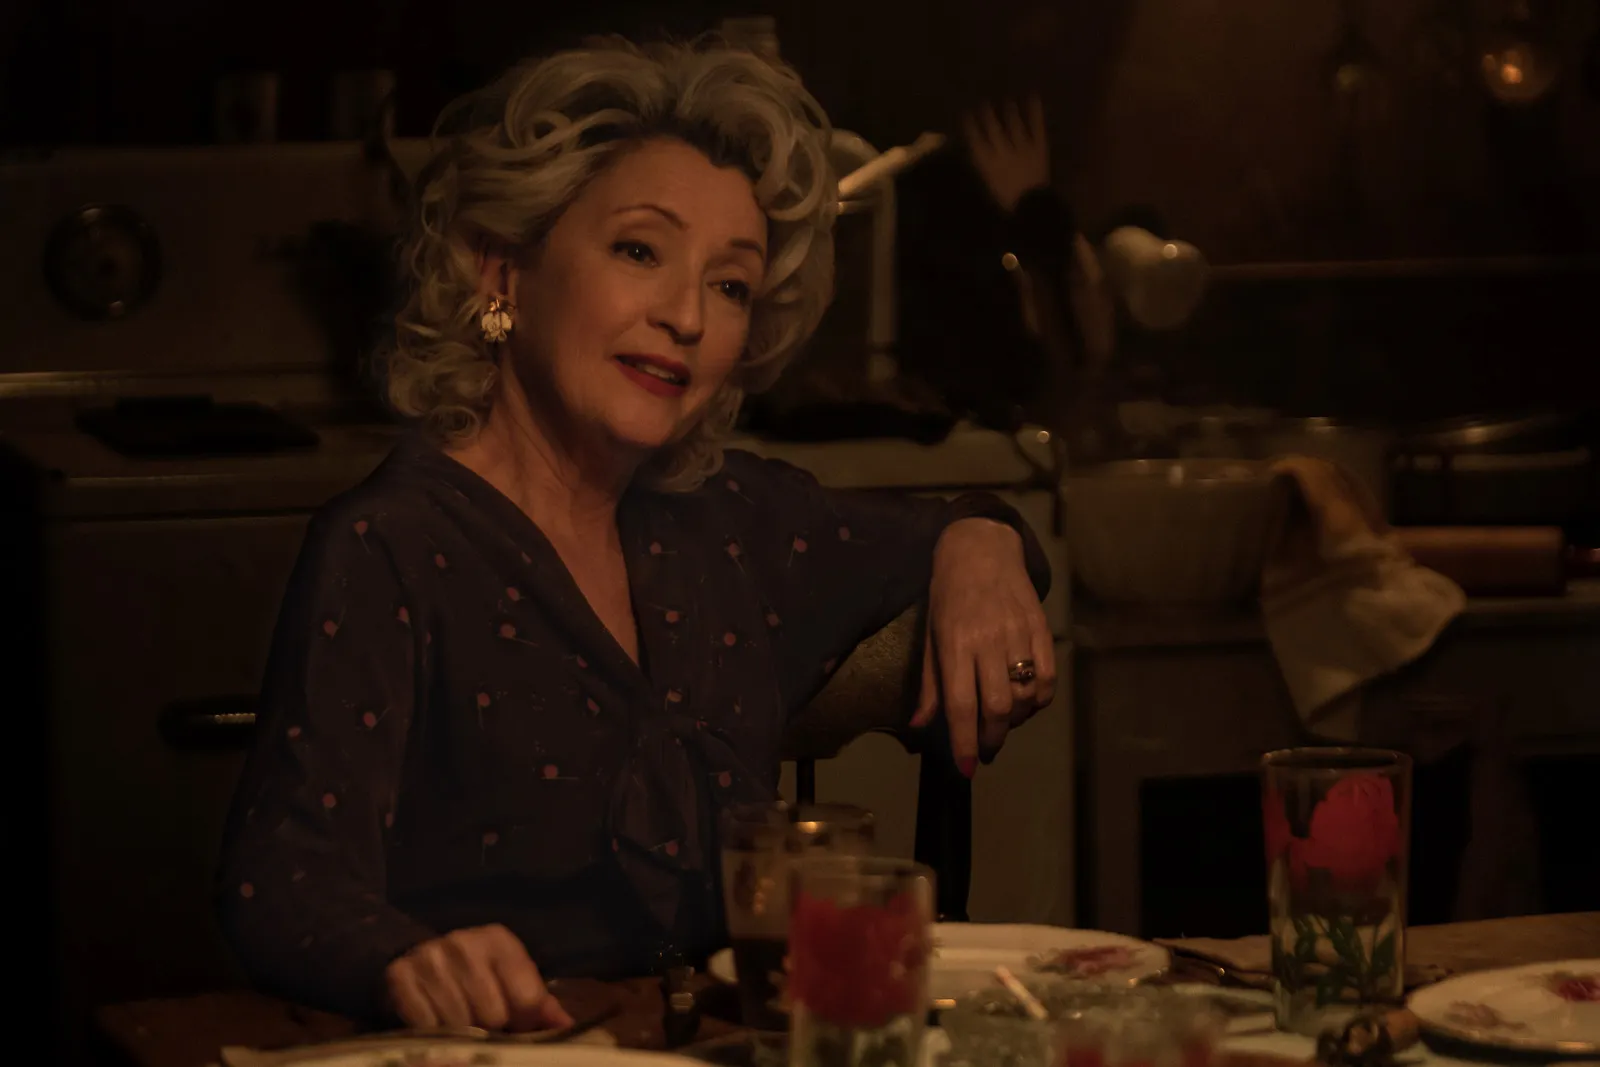&#60;image&#62;
Describe the following image. The image presents an elderly woman with styled gray hair, seated comfortably at a kitchen table. She is dressed in a murky blue blouse speckled with bright decorative elements that provide a soft touch of color to her outfit. The table showcases a humble meal accompanied by a glass, and the background features a homey kitchen setting with pot and pans, evoking a warm and rustic ambiance. This scene might suggest a moment of daily life, capturing the woman in a serene, reflective pause, perhaps enjoying a meal in solitude. 